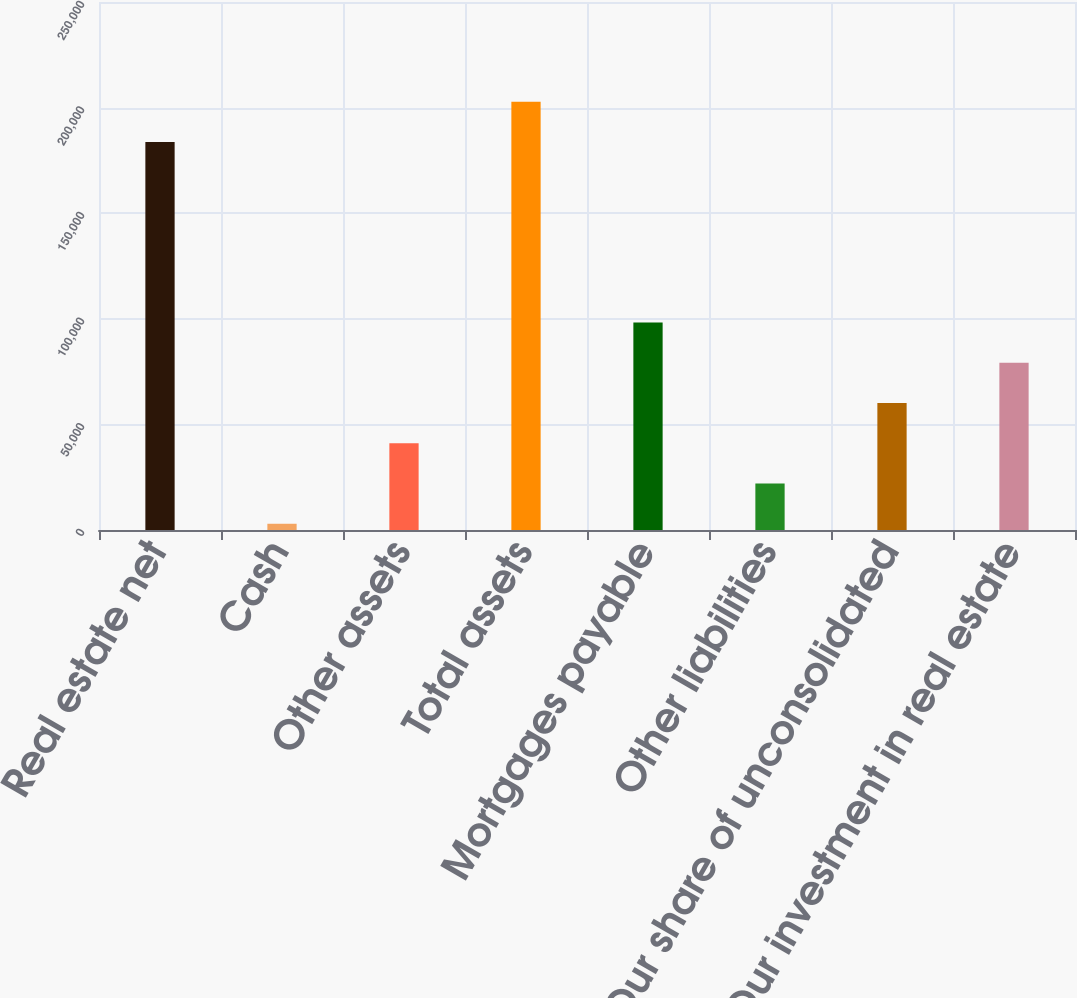Convert chart to OTSL. <chart><loc_0><loc_0><loc_500><loc_500><bar_chart><fcel>Real estate net<fcel>Cash<fcel>Other assets<fcel>Total assets<fcel>Mortgages payable<fcel>Other liabilities<fcel>Our share of unconsolidated<fcel>Our investment in real estate<nl><fcel>183757<fcel>2959<fcel>41081<fcel>202818<fcel>98264<fcel>22020<fcel>60142<fcel>79203<nl></chart> 